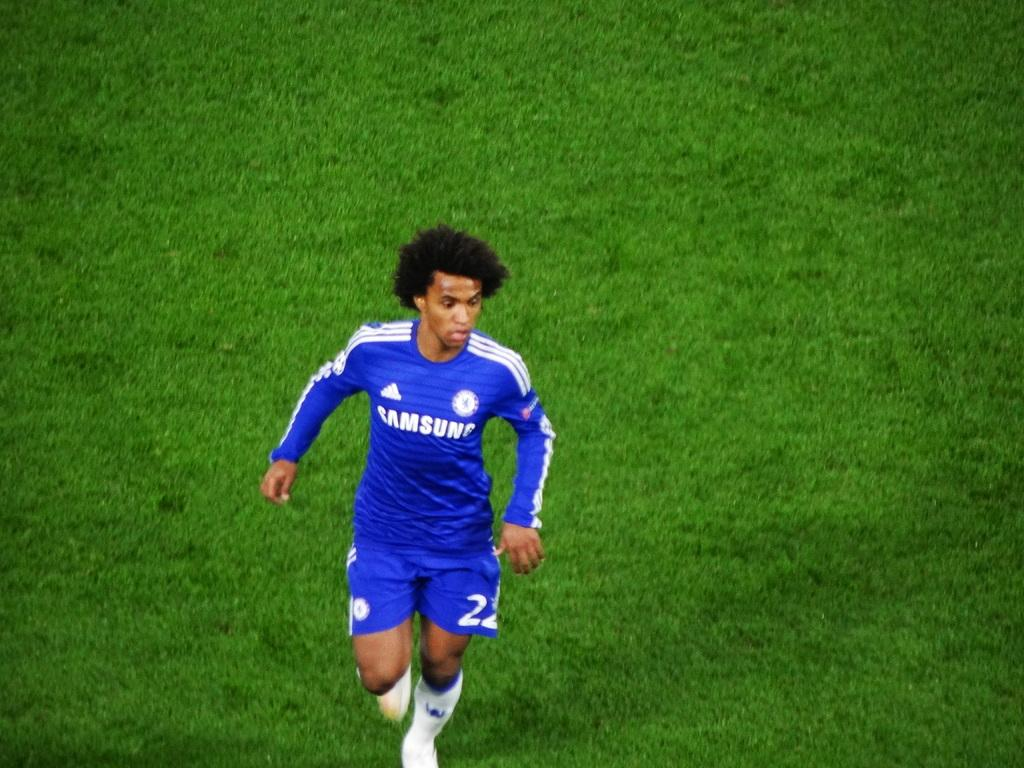Provide a one-sentence caption for the provided image. A man in a blue Samsung uniform jogs across the field. 